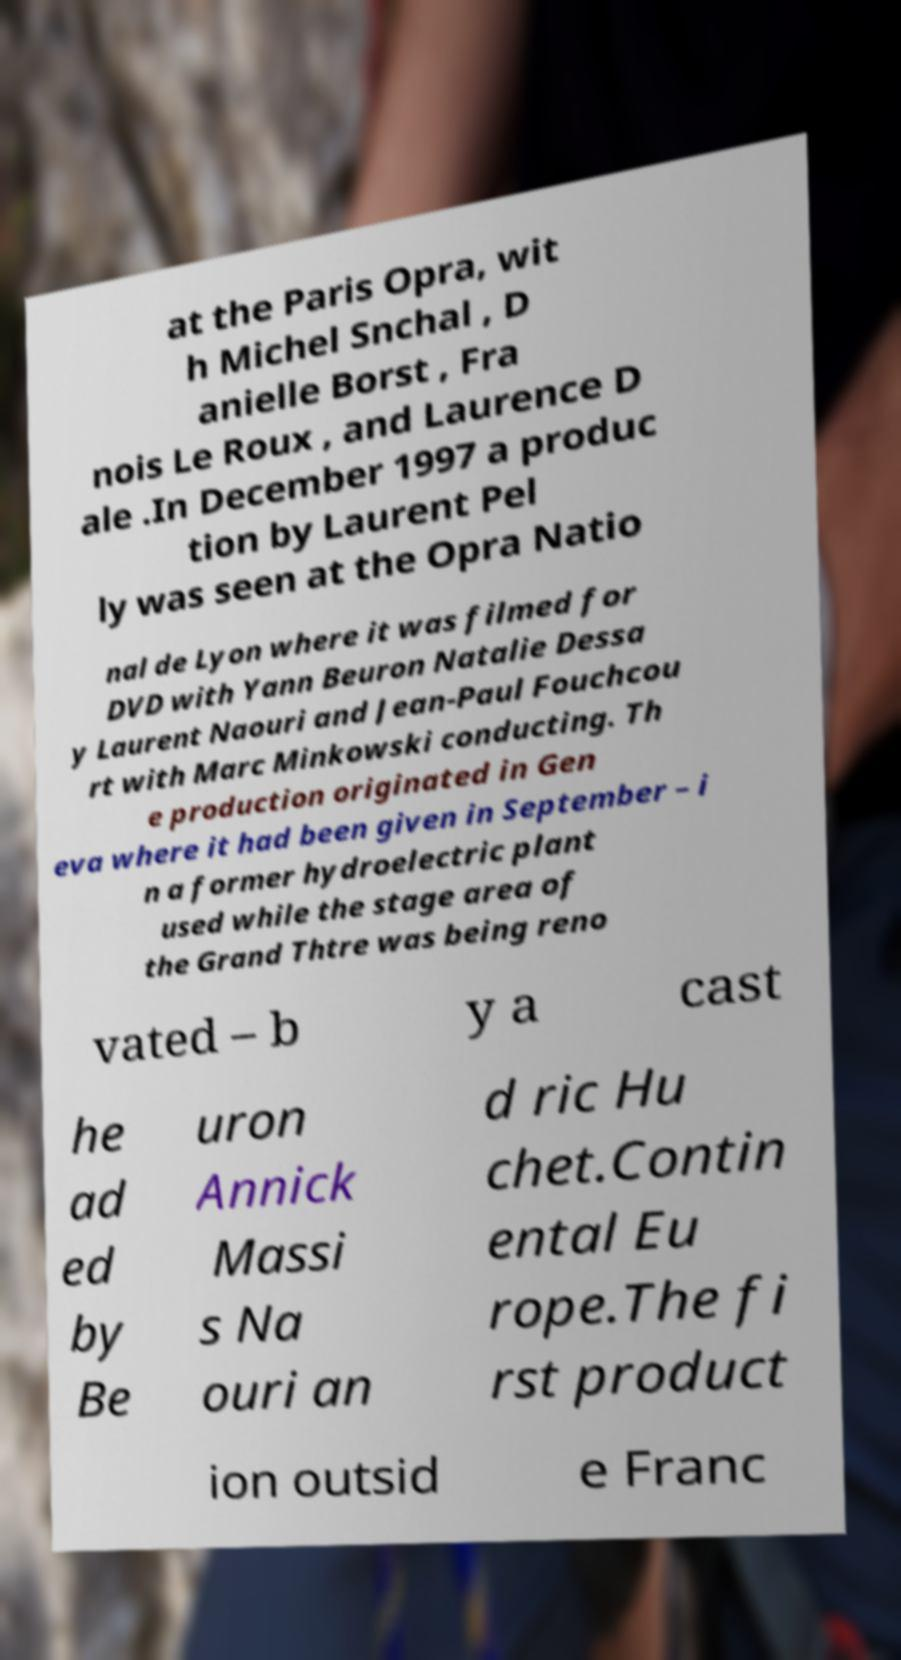Could you assist in decoding the text presented in this image and type it out clearly? at the Paris Opra, wit h Michel Snchal , D anielle Borst , Fra nois Le Roux , and Laurence D ale .In December 1997 a produc tion by Laurent Pel ly was seen at the Opra Natio nal de Lyon where it was filmed for DVD with Yann Beuron Natalie Dessa y Laurent Naouri and Jean-Paul Fouchcou rt with Marc Minkowski conducting. Th e production originated in Gen eva where it had been given in September – i n a former hydroelectric plant used while the stage area of the Grand Thtre was being reno vated – b y a cast he ad ed by Be uron Annick Massi s Na ouri an d ric Hu chet.Contin ental Eu rope.The fi rst product ion outsid e Franc 